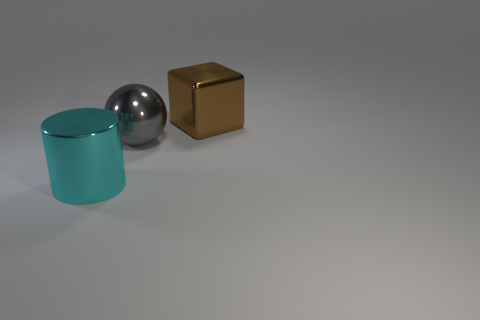There is a object to the right of the shiny ball; is it the same size as the big gray sphere?
Give a very brief answer. Yes. Is the big brown cube made of the same material as the large thing in front of the gray thing?
Offer a very short reply. Yes. There is a thing that is left of the big gray metal sphere; what color is it?
Ensure brevity in your answer.  Cyan. Is there a large cube that is to the left of the metallic object that is on the left side of the large gray metallic ball?
Offer a terse response. No. Do the thing right of the gray shiny thing and the object that is on the left side of the metallic ball have the same color?
Make the answer very short. No. What number of big brown blocks are right of the large brown thing?
Your answer should be very brief. 0. How many cylinders have the same color as the big block?
Offer a terse response. 0. Does the object behind the metallic ball have the same material as the big cylinder?
Offer a very short reply. Yes. What number of big gray balls are made of the same material as the brown thing?
Make the answer very short. 1. Are there more gray things behind the brown block than brown shiny objects?
Keep it short and to the point. No. 